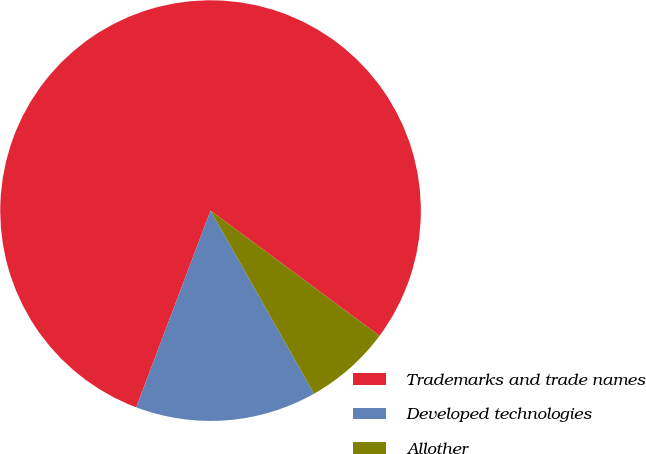<chart> <loc_0><loc_0><loc_500><loc_500><pie_chart><fcel>Trademarks and trade names<fcel>Developed technologies<fcel>Allother<nl><fcel>79.4%<fcel>13.94%<fcel>6.66%<nl></chart> 